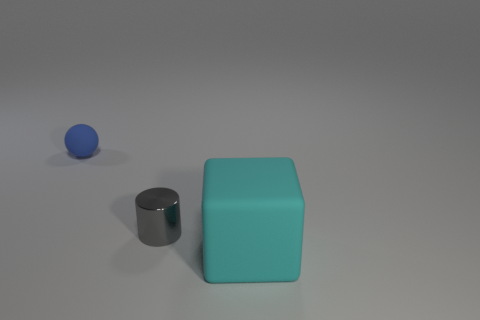What material is the gray cylinder?
Make the answer very short. Metal. There is a thing that is both to the right of the blue thing and behind the cyan thing; how big is it?
Keep it short and to the point. Small. How many large yellow metal objects are there?
Ensure brevity in your answer.  0. Are there fewer blue metal cylinders than blue matte objects?
Provide a succinct answer. Yes. What is the material of the blue object that is the same size as the gray metal cylinder?
Provide a succinct answer. Rubber. What number of objects are either red rubber cubes or gray metal things?
Give a very brief answer. 1. What number of matte objects are both in front of the small gray metal object and behind the big cyan matte cube?
Ensure brevity in your answer.  0. Is the number of cyan cubes that are on the left side of the tiny gray shiny cylinder less than the number of big purple matte cylinders?
Keep it short and to the point. No. There is a gray thing that is the same size as the matte sphere; what shape is it?
Ensure brevity in your answer.  Cylinder. Does the blue matte thing have the same size as the rubber block?
Make the answer very short. No. 